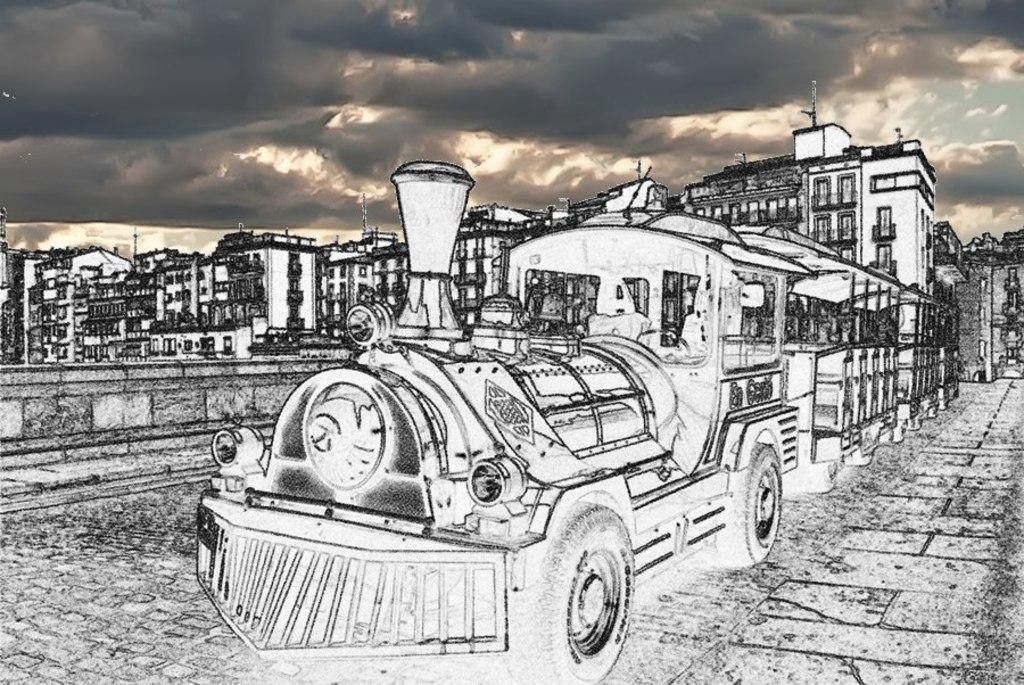What is the main subject of the image? The main subject of the image is a train. Where is the train located in the image? The train is in front of the picture. What is at the bottom of the image? There is a pavement at the bottom of the image. What can be seen in the background of the image? There are buildings and poles in the background of the image. What is visible at the top of the image? The sky is visible at the top of the image. Can you tell me how many chess pieces are on the train in the image? There are no chess pieces visible on the train in the image. What type of plane can be seen flying in the sky in the image? There are no planes visible in the sky in the image. 